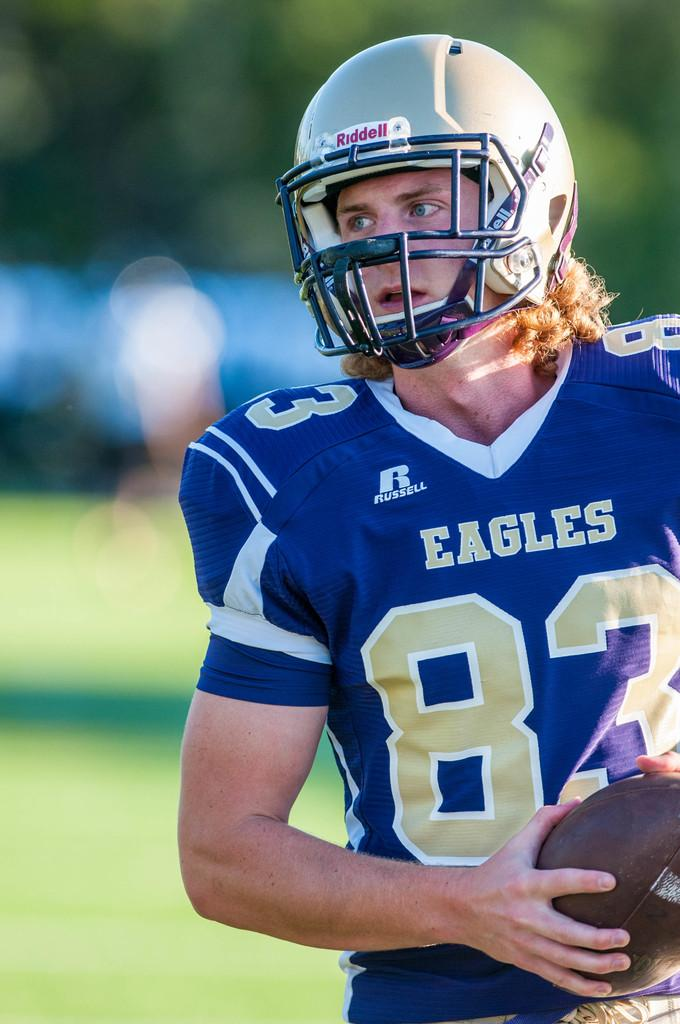Who is present in the image? There is a man in the image. What is the man wearing? The man is wearing a sports dress. What is the man holding in the image? The man is holding a ball. What type of protective gear is the man wearing? The man is wearing a helmet. Can you describe the background of the image? The background of the image is blurred. How much money is the man holding in the image? The man is not holding any money in the image; he is holding a ball. What type of animal can be seen interacting with the man in the image? There are no animals present in the image; it only features the man and the ball. 